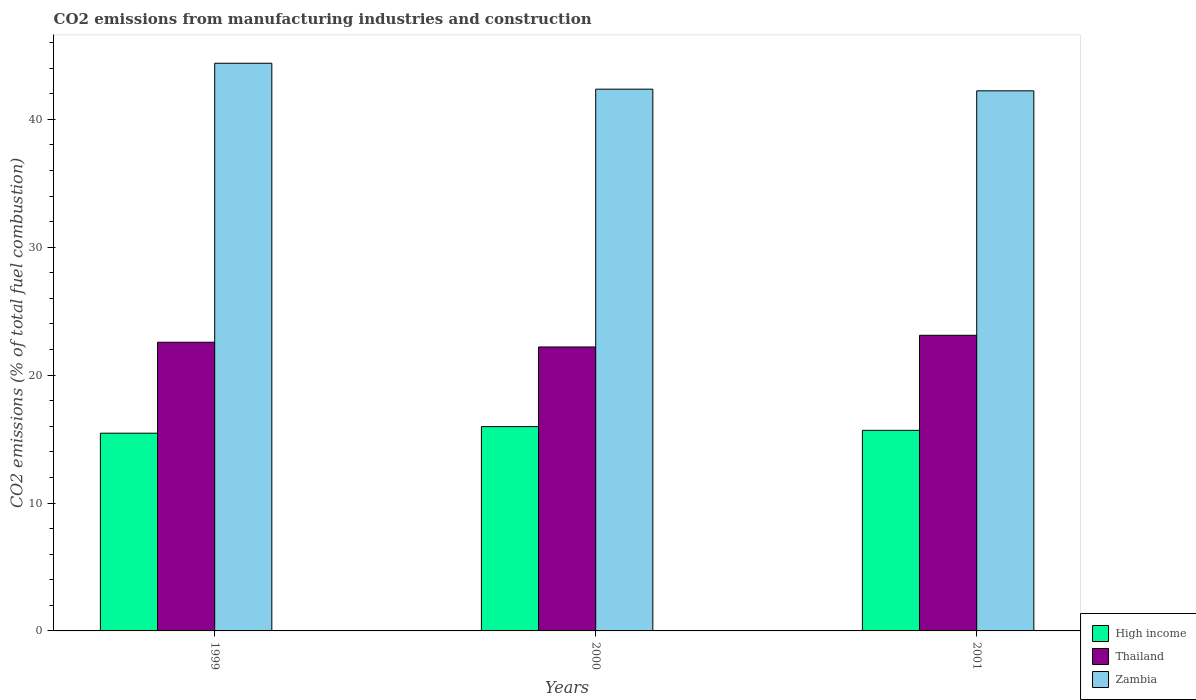How many different coloured bars are there?
Give a very brief answer. 3. How many bars are there on the 1st tick from the left?
Your answer should be very brief. 3. What is the amount of CO2 emitted in Thailand in 1999?
Make the answer very short. 22.57. Across all years, what is the maximum amount of CO2 emitted in High income?
Your answer should be very brief. 15.97. Across all years, what is the minimum amount of CO2 emitted in Zambia?
Give a very brief answer. 42.22. What is the total amount of CO2 emitted in Thailand in the graph?
Keep it short and to the point. 67.88. What is the difference between the amount of CO2 emitted in Thailand in 2000 and that in 2001?
Offer a very short reply. -0.91. What is the difference between the amount of CO2 emitted in Zambia in 2001 and the amount of CO2 emitted in Thailand in 1999?
Keep it short and to the point. 19.65. What is the average amount of CO2 emitted in Thailand per year?
Your answer should be compact. 22.63. In the year 2001, what is the difference between the amount of CO2 emitted in Zambia and amount of CO2 emitted in High income?
Your answer should be very brief. 26.54. What is the ratio of the amount of CO2 emitted in Zambia in 1999 to that in 2000?
Your answer should be very brief. 1.05. Is the difference between the amount of CO2 emitted in Zambia in 1999 and 2000 greater than the difference between the amount of CO2 emitted in High income in 1999 and 2000?
Offer a very short reply. Yes. What is the difference between the highest and the second highest amount of CO2 emitted in High income?
Keep it short and to the point. 0.29. What is the difference between the highest and the lowest amount of CO2 emitted in High income?
Ensure brevity in your answer.  0.52. Is the sum of the amount of CO2 emitted in Thailand in 1999 and 2000 greater than the maximum amount of CO2 emitted in Zambia across all years?
Give a very brief answer. Yes. What does the 2nd bar from the left in 2001 represents?
Your answer should be compact. Thailand. What does the 3rd bar from the right in 1999 represents?
Provide a succinct answer. High income. Is it the case that in every year, the sum of the amount of CO2 emitted in High income and amount of CO2 emitted in Thailand is greater than the amount of CO2 emitted in Zambia?
Provide a succinct answer. No. Are all the bars in the graph horizontal?
Offer a very short reply. No. What is the difference between two consecutive major ticks on the Y-axis?
Keep it short and to the point. 10. Does the graph contain any zero values?
Make the answer very short. No. Does the graph contain grids?
Provide a short and direct response. No. Where does the legend appear in the graph?
Provide a succinct answer. Bottom right. How many legend labels are there?
Provide a short and direct response. 3. How are the legend labels stacked?
Ensure brevity in your answer.  Vertical. What is the title of the graph?
Your answer should be very brief. CO2 emissions from manufacturing industries and construction. Does "Botswana" appear as one of the legend labels in the graph?
Your answer should be very brief. No. What is the label or title of the Y-axis?
Your answer should be compact. CO2 emissions (% of total fuel combustion). What is the CO2 emissions (% of total fuel combustion) of High income in 1999?
Provide a short and direct response. 15.46. What is the CO2 emissions (% of total fuel combustion) in Thailand in 1999?
Your answer should be compact. 22.57. What is the CO2 emissions (% of total fuel combustion) of Zambia in 1999?
Your response must be concise. 44.38. What is the CO2 emissions (% of total fuel combustion) of High income in 2000?
Provide a short and direct response. 15.97. What is the CO2 emissions (% of total fuel combustion) of Thailand in 2000?
Make the answer very short. 22.2. What is the CO2 emissions (% of total fuel combustion) in Zambia in 2000?
Offer a very short reply. 42.35. What is the CO2 emissions (% of total fuel combustion) of High income in 2001?
Your response must be concise. 15.68. What is the CO2 emissions (% of total fuel combustion) of Thailand in 2001?
Provide a succinct answer. 23.11. What is the CO2 emissions (% of total fuel combustion) of Zambia in 2001?
Your answer should be very brief. 42.22. Across all years, what is the maximum CO2 emissions (% of total fuel combustion) in High income?
Provide a short and direct response. 15.97. Across all years, what is the maximum CO2 emissions (% of total fuel combustion) of Thailand?
Your answer should be compact. 23.11. Across all years, what is the maximum CO2 emissions (% of total fuel combustion) in Zambia?
Your answer should be very brief. 44.38. Across all years, what is the minimum CO2 emissions (% of total fuel combustion) in High income?
Your response must be concise. 15.46. Across all years, what is the minimum CO2 emissions (% of total fuel combustion) of Thailand?
Your answer should be compact. 22.2. Across all years, what is the minimum CO2 emissions (% of total fuel combustion) in Zambia?
Give a very brief answer. 42.22. What is the total CO2 emissions (% of total fuel combustion) in High income in the graph?
Offer a very short reply. 47.11. What is the total CO2 emissions (% of total fuel combustion) in Thailand in the graph?
Keep it short and to the point. 67.88. What is the total CO2 emissions (% of total fuel combustion) in Zambia in the graph?
Offer a terse response. 128.95. What is the difference between the CO2 emissions (% of total fuel combustion) of High income in 1999 and that in 2000?
Provide a succinct answer. -0.52. What is the difference between the CO2 emissions (% of total fuel combustion) in Thailand in 1999 and that in 2000?
Your answer should be very brief. 0.37. What is the difference between the CO2 emissions (% of total fuel combustion) in Zambia in 1999 and that in 2000?
Provide a short and direct response. 2.03. What is the difference between the CO2 emissions (% of total fuel combustion) in High income in 1999 and that in 2001?
Your answer should be compact. -0.22. What is the difference between the CO2 emissions (% of total fuel combustion) of Thailand in 1999 and that in 2001?
Your response must be concise. -0.54. What is the difference between the CO2 emissions (% of total fuel combustion) in Zambia in 1999 and that in 2001?
Offer a terse response. 2.16. What is the difference between the CO2 emissions (% of total fuel combustion) in High income in 2000 and that in 2001?
Ensure brevity in your answer.  0.29. What is the difference between the CO2 emissions (% of total fuel combustion) of Thailand in 2000 and that in 2001?
Keep it short and to the point. -0.91. What is the difference between the CO2 emissions (% of total fuel combustion) in Zambia in 2000 and that in 2001?
Your response must be concise. 0.13. What is the difference between the CO2 emissions (% of total fuel combustion) of High income in 1999 and the CO2 emissions (% of total fuel combustion) of Thailand in 2000?
Your answer should be very brief. -6.74. What is the difference between the CO2 emissions (% of total fuel combustion) in High income in 1999 and the CO2 emissions (% of total fuel combustion) in Zambia in 2000?
Your answer should be compact. -26.9. What is the difference between the CO2 emissions (% of total fuel combustion) of Thailand in 1999 and the CO2 emissions (% of total fuel combustion) of Zambia in 2000?
Provide a succinct answer. -19.78. What is the difference between the CO2 emissions (% of total fuel combustion) in High income in 1999 and the CO2 emissions (% of total fuel combustion) in Thailand in 2001?
Your response must be concise. -7.65. What is the difference between the CO2 emissions (% of total fuel combustion) of High income in 1999 and the CO2 emissions (% of total fuel combustion) of Zambia in 2001?
Provide a short and direct response. -26.76. What is the difference between the CO2 emissions (% of total fuel combustion) in Thailand in 1999 and the CO2 emissions (% of total fuel combustion) in Zambia in 2001?
Give a very brief answer. -19.65. What is the difference between the CO2 emissions (% of total fuel combustion) in High income in 2000 and the CO2 emissions (% of total fuel combustion) in Thailand in 2001?
Provide a succinct answer. -7.14. What is the difference between the CO2 emissions (% of total fuel combustion) of High income in 2000 and the CO2 emissions (% of total fuel combustion) of Zambia in 2001?
Ensure brevity in your answer.  -26.25. What is the difference between the CO2 emissions (% of total fuel combustion) in Thailand in 2000 and the CO2 emissions (% of total fuel combustion) in Zambia in 2001?
Give a very brief answer. -20.02. What is the average CO2 emissions (% of total fuel combustion) of High income per year?
Your answer should be compact. 15.7. What is the average CO2 emissions (% of total fuel combustion) of Thailand per year?
Provide a succinct answer. 22.63. What is the average CO2 emissions (% of total fuel combustion) in Zambia per year?
Make the answer very short. 42.98. In the year 1999, what is the difference between the CO2 emissions (% of total fuel combustion) in High income and CO2 emissions (% of total fuel combustion) in Thailand?
Ensure brevity in your answer.  -7.11. In the year 1999, what is the difference between the CO2 emissions (% of total fuel combustion) in High income and CO2 emissions (% of total fuel combustion) in Zambia?
Offer a very short reply. -28.92. In the year 1999, what is the difference between the CO2 emissions (% of total fuel combustion) in Thailand and CO2 emissions (% of total fuel combustion) in Zambia?
Provide a short and direct response. -21.81. In the year 2000, what is the difference between the CO2 emissions (% of total fuel combustion) in High income and CO2 emissions (% of total fuel combustion) in Thailand?
Offer a terse response. -6.22. In the year 2000, what is the difference between the CO2 emissions (% of total fuel combustion) of High income and CO2 emissions (% of total fuel combustion) of Zambia?
Make the answer very short. -26.38. In the year 2000, what is the difference between the CO2 emissions (% of total fuel combustion) of Thailand and CO2 emissions (% of total fuel combustion) of Zambia?
Offer a terse response. -20.15. In the year 2001, what is the difference between the CO2 emissions (% of total fuel combustion) in High income and CO2 emissions (% of total fuel combustion) in Thailand?
Give a very brief answer. -7.43. In the year 2001, what is the difference between the CO2 emissions (% of total fuel combustion) of High income and CO2 emissions (% of total fuel combustion) of Zambia?
Your answer should be compact. -26.54. In the year 2001, what is the difference between the CO2 emissions (% of total fuel combustion) in Thailand and CO2 emissions (% of total fuel combustion) in Zambia?
Make the answer very short. -19.11. What is the ratio of the CO2 emissions (% of total fuel combustion) in Thailand in 1999 to that in 2000?
Make the answer very short. 1.02. What is the ratio of the CO2 emissions (% of total fuel combustion) in Zambia in 1999 to that in 2000?
Offer a terse response. 1.05. What is the ratio of the CO2 emissions (% of total fuel combustion) of High income in 1999 to that in 2001?
Give a very brief answer. 0.99. What is the ratio of the CO2 emissions (% of total fuel combustion) of Thailand in 1999 to that in 2001?
Offer a very short reply. 0.98. What is the ratio of the CO2 emissions (% of total fuel combustion) of Zambia in 1999 to that in 2001?
Your answer should be very brief. 1.05. What is the ratio of the CO2 emissions (% of total fuel combustion) of High income in 2000 to that in 2001?
Give a very brief answer. 1.02. What is the ratio of the CO2 emissions (% of total fuel combustion) in Thailand in 2000 to that in 2001?
Offer a very short reply. 0.96. What is the ratio of the CO2 emissions (% of total fuel combustion) of Zambia in 2000 to that in 2001?
Ensure brevity in your answer.  1. What is the difference between the highest and the second highest CO2 emissions (% of total fuel combustion) of High income?
Make the answer very short. 0.29. What is the difference between the highest and the second highest CO2 emissions (% of total fuel combustion) in Thailand?
Your response must be concise. 0.54. What is the difference between the highest and the second highest CO2 emissions (% of total fuel combustion) in Zambia?
Offer a terse response. 2.03. What is the difference between the highest and the lowest CO2 emissions (% of total fuel combustion) in High income?
Give a very brief answer. 0.52. What is the difference between the highest and the lowest CO2 emissions (% of total fuel combustion) in Thailand?
Ensure brevity in your answer.  0.91. What is the difference between the highest and the lowest CO2 emissions (% of total fuel combustion) in Zambia?
Provide a short and direct response. 2.16. 